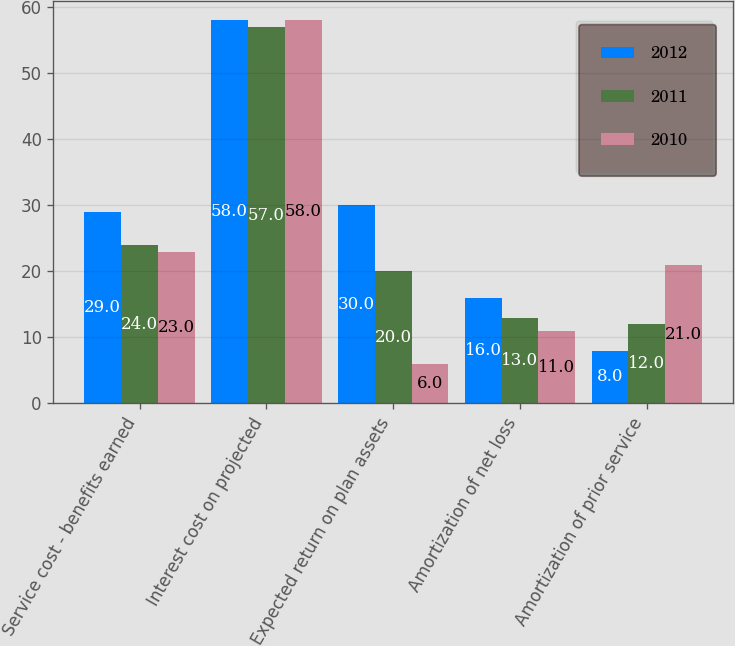Convert chart to OTSL. <chart><loc_0><loc_0><loc_500><loc_500><stacked_bar_chart><ecel><fcel>Service cost - benefits earned<fcel>Interest cost on projected<fcel>Expected return on plan assets<fcel>Amortization of net loss<fcel>Amortization of prior service<nl><fcel>2012<fcel>29<fcel>58<fcel>30<fcel>16<fcel>8<nl><fcel>2011<fcel>24<fcel>57<fcel>20<fcel>13<fcel>12<nl><fcel>2010<fcel>23<fcel>58<fcel>6<fcel>11<fcel>21<nl></chart> 